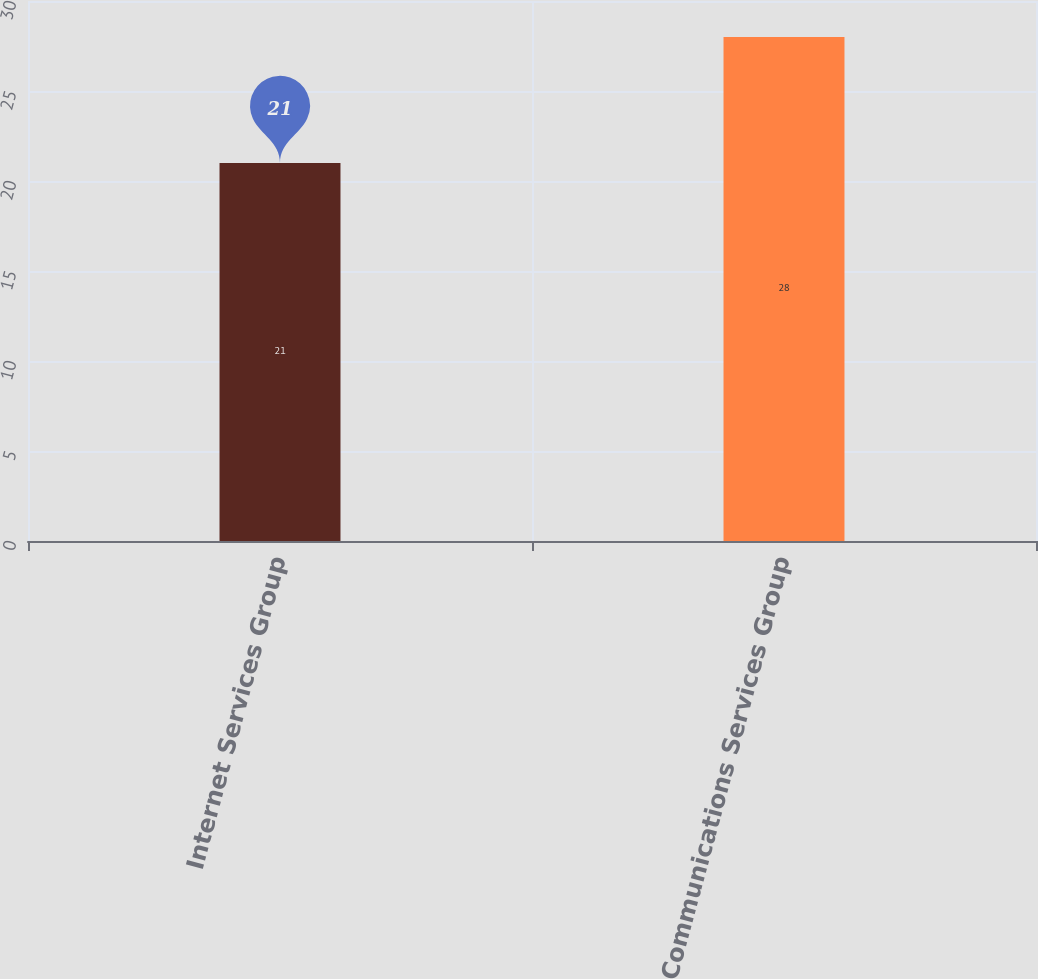Convert chart to OTSL. <chart><loc_0><loc_0><loc_500><loc_500><bar_chart><fcel>Internet Services Group<fcel>Communications Services Group<nl><fcel>21<fcel>28<nl></chart> 